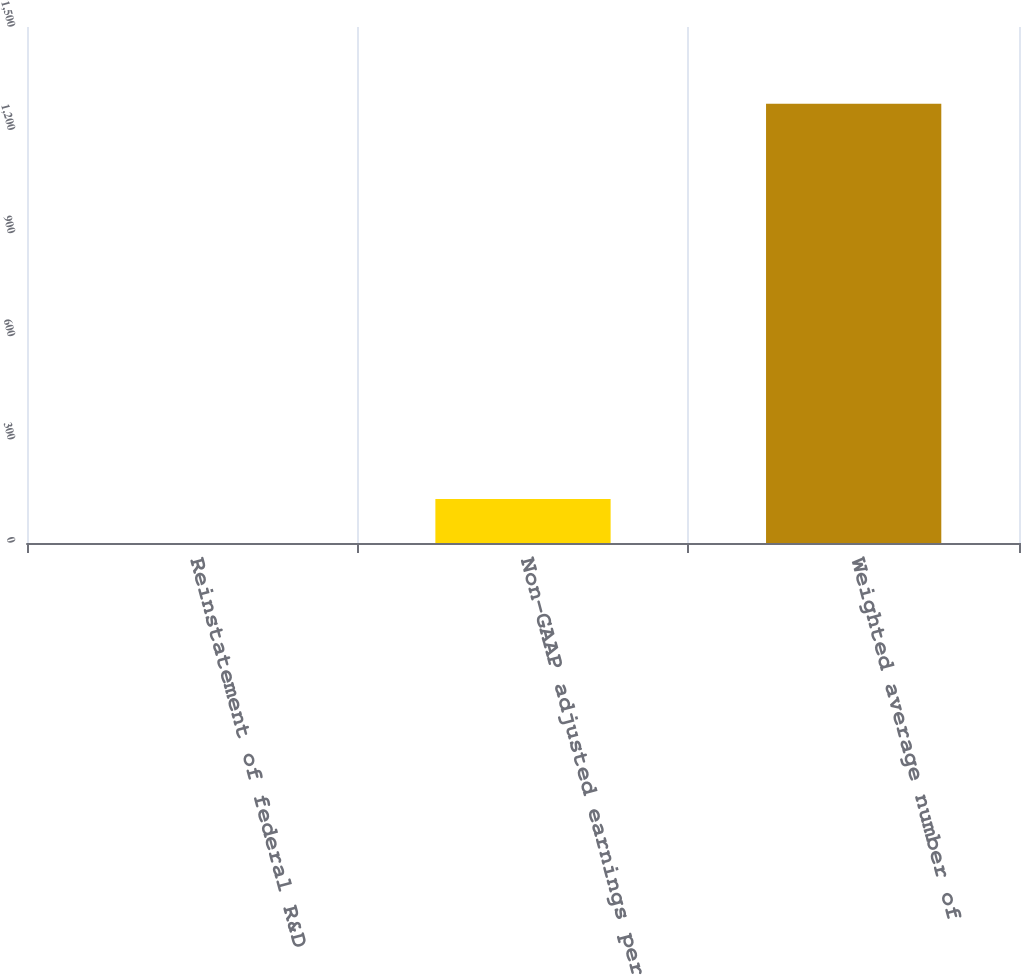Convert chart. <chart><loc_0><loc_0><loc_500><loc_500><bar_chart><fcel>Reinstatement of federal R&D<fcel>Non-GAAP adjusted earnings per<fcel>Weighted average number of<nl><fcel>0.02<fcel>127.72<fcel>1277<nl></chart> 